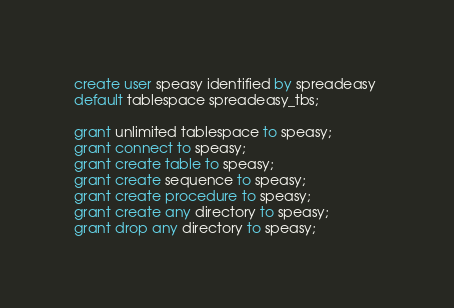Convert code to text. <code><loc_0><loc_0><loc_500><loc_500><_SQL_>create user speasy identified by spreadeasy 
default tablespace spreadeasy_tbs;

grant unlimited tablespace to speasy;
grant connect to speasy;
grant create table to speasy;
grant create sequence to speasy;
grant create procedure to speasy;
grant create any directory to speasy;
grant drop any directory to speasy;</code> 